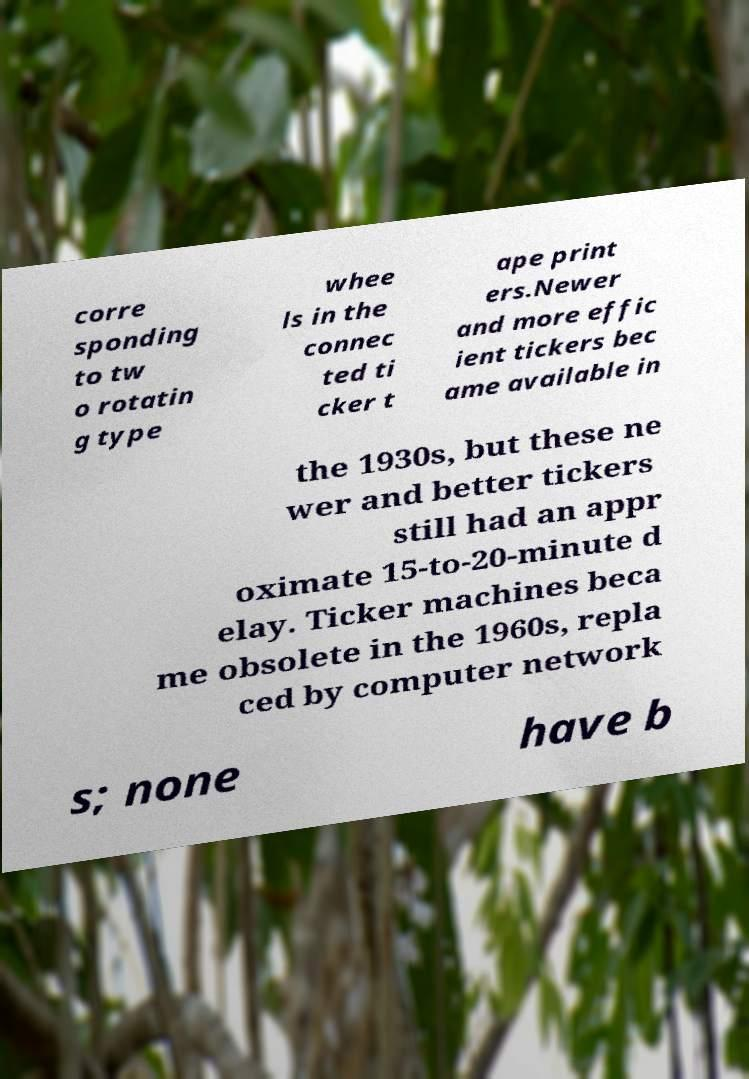Can you accurately transcribe the text from the provided image for me? corre sponding to tw o rotatin g type whee ls in the connec ted ti cker t ape print ers.Newer and more effic ient tickers bec ame available in the 1930s, but these ne wer and better tickers still had an appr oximate 15-to-20-minute d elay. Ticker machines beca me obsolete in the 1960s, repla ced by computer network s; none have b 